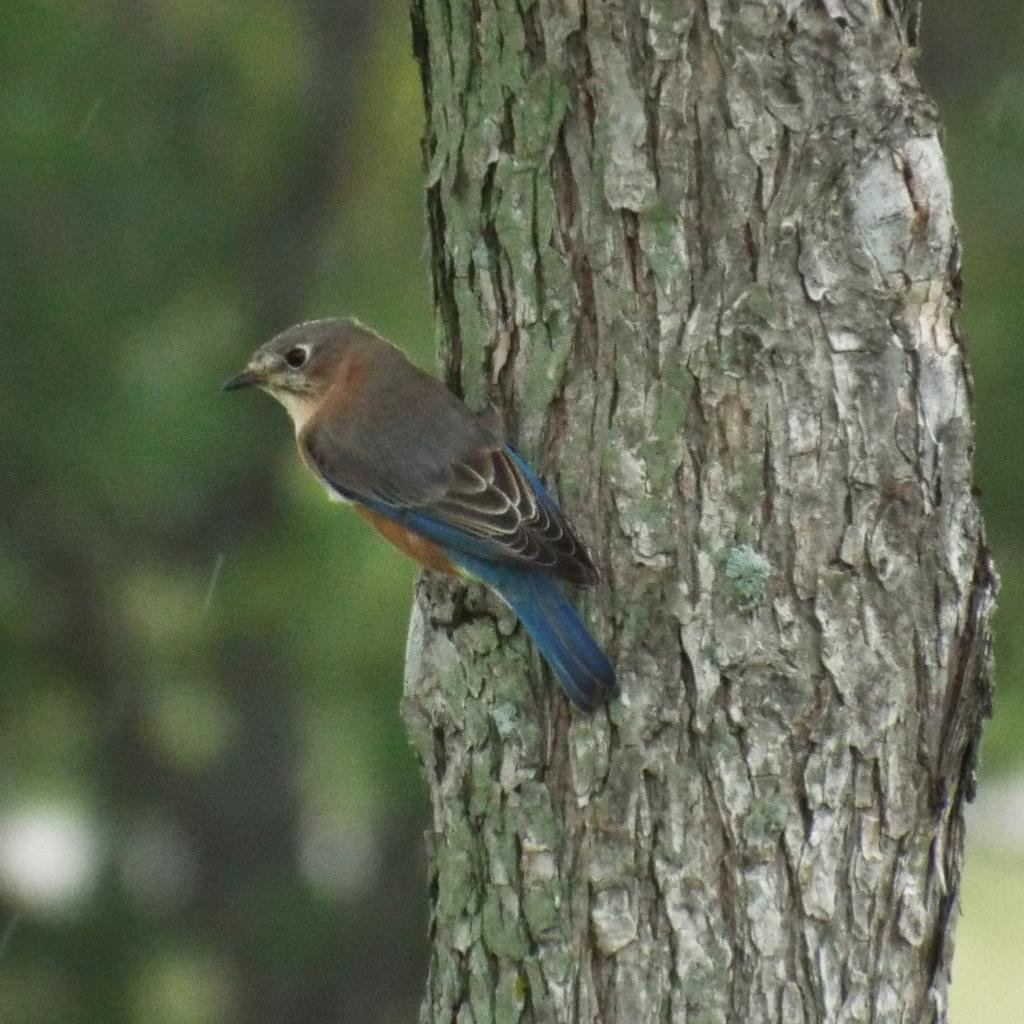What type of animal can be seen in the image? There is a bird in the image. Where is the bird located? The bird is on a tree trunk. Can you describe the background of the image? The background of the image is blurry. What type of popcorn is the bird eating in the image? There is no popcorn present in the image; the bird is on a tree trunk. Can you see any snails in the image? There are no snails visible in the image. 